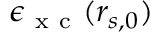Convert formula to latex. <formula><loc_0><loc_0><loc_500><loc_500>\epsilon _ { x c } ( r _ { s , 0 } )</formula> 